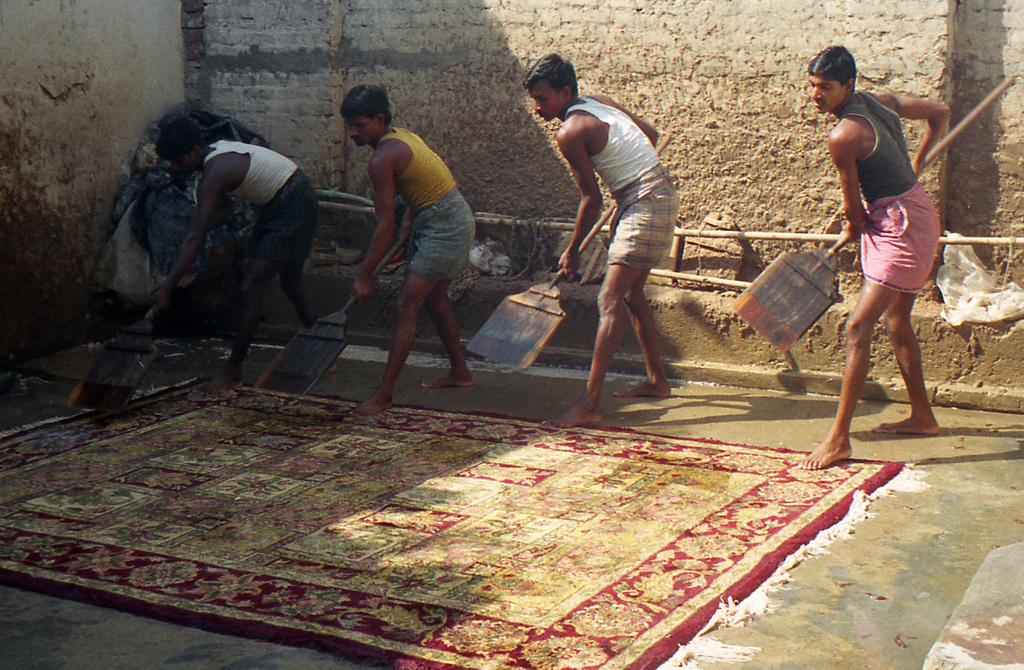How many people are in the image? There are four people in the image. What are the people holding in the image? The people are holding brooms. What are the people doing with the brooms? The people are cleaning a carpet. Where is the carpet located in the image? The carpet is on the ground. What type of tomatoes can be seen growing on the carpet in the image? There are no tomatoes present in the image, and the carpet is not a growing medium for plants. 